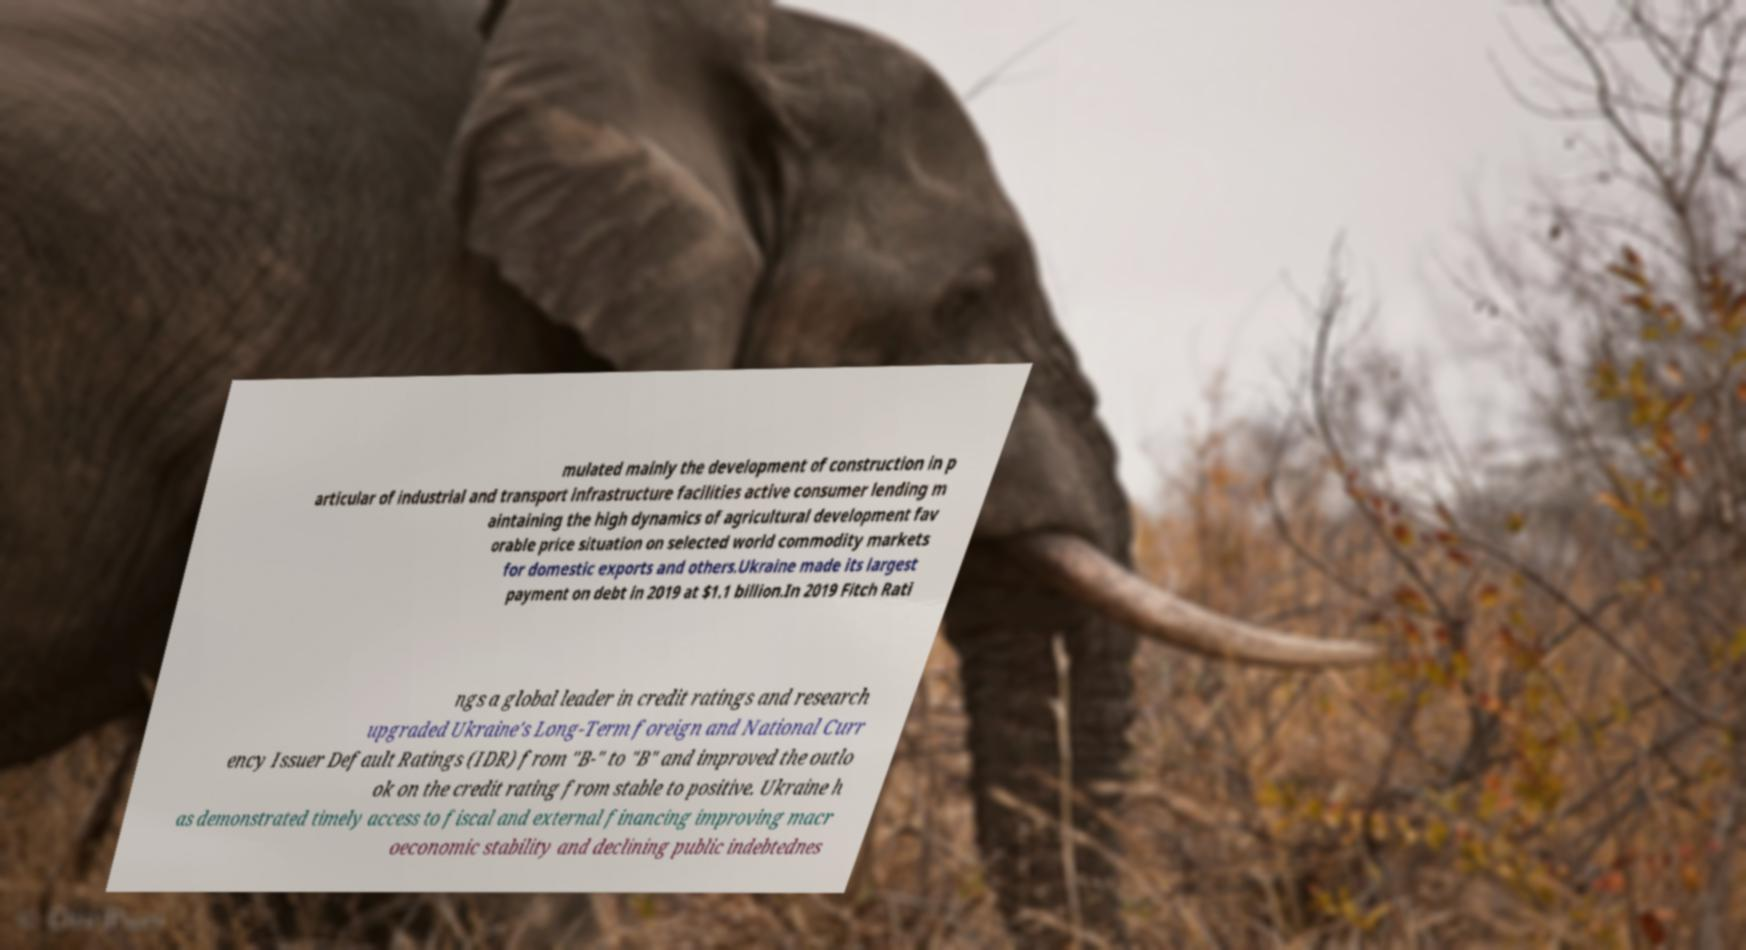For documentation purposes, I need the text within this image transcribed. Could you provide that? mulated mainly the development of construction in p articular of industrial and transport infrastructure facilities active consumer lending m aintaining the high dynamics of agricultural development fav orable price situation on selected world commodity markets for domestic exports and others.Ukraine made its largest payment on debt in 2019 at $1.1 billion.In 2019 Fitch Rati ngs a global leader in credit ratings and research upgraded Ukraine's Long-Term foreign and National Curr ency Issuer Default Ratings (IDR) from "B-" to "B" and improved the outlo ok on the credit rating from stable to positive. Ukraine h as demonstrated timely access to fiscal and external financing improving macr oeconomic stability and declining public indebtednes 